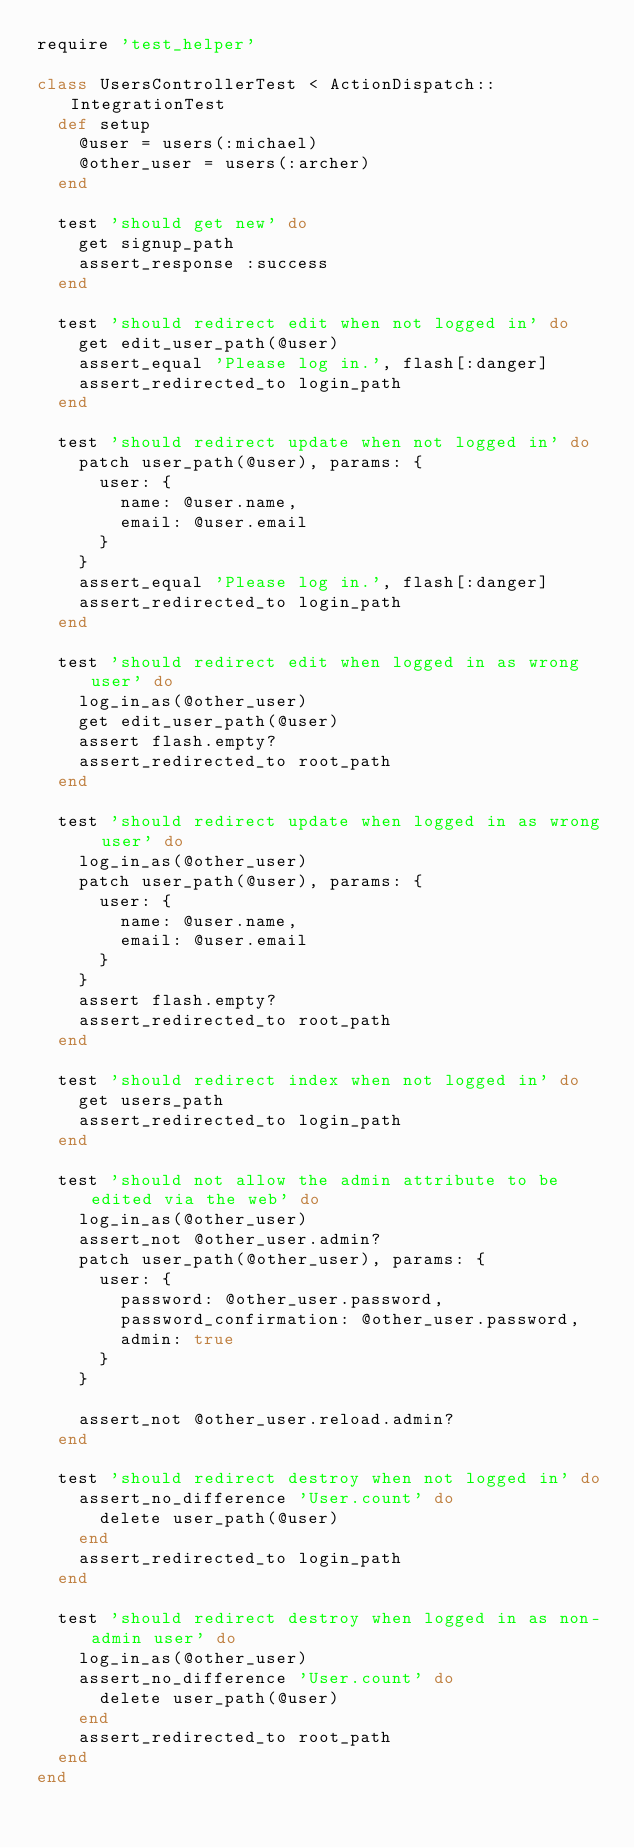<code> <loc_0><loc_0><loc_500><loc_500><_Ruby_>require 'test_helper'

class UsersControllerTest < ActionDispatch::IntegrationTest
  def setup
    @user = users(:michael)
    @other_user = users(:archer)
  end

  test 'should get new' do
    get signup_path
    assert_response :success
  end

  test 'should redirect edit when not logged in' do
    get edit_user_path(@user)
    assert_equal 'Please log in.', flash[:danger]
    assert_redirected_to login_path
  end

  test 'should redirect update when not logged in' do
    patch user_path(@user), params: {
      user: {
        name: @user.name,
        email: @user.email
      }
    }
    assert_equal 'Please log in.', flash[:danger]
    assert_redirected_to login_path
  end

  test 'should redirect edit when logged in as wrong user' do
    log_in_as(@other_user)
    get edit_user_path(@user)
    assert flash.empty?
    assert_redirected_to root_path
  end

  test 'should redirect update when logged in as wrong user' do
    log_in_as(@other_user)
    patch user_path(@user), params: {
      user: {
        name: @user.name,
        email: @user.email
      }
    }
    assert flash.empty?
    assert_redirected_to root_path
  end

  test 'should redirect index when not logged in' do
    get users_path
    assert_redirected_to login_path
  end

  test 'should not allow the admin attribute to be edited via the web' do
    log_in_as(@other_user)
    assert_not @other_user.admin?
    patch user_path(@other_user), params: {
      user: {
        password: @other_user.password,
        password_confirmation: @other_user.password,
        admin: true
      }
    }

    assert_not @other_user.reload.admin?
  end

  test 'should redirect destroy when not logged in' do
    assert_no_difference 'User.count' do
      delete user_path(@user)
    end
    assert_redirected_to login_path
  end

  test 'should redirect destroy when logged in as non-admin user' do
    log_in_as(@other_user)
    assert_no_difference 'User.count' do
      delete user_path(@user)
    end
    assert_redirected_to root_path
  end
end
</code> 